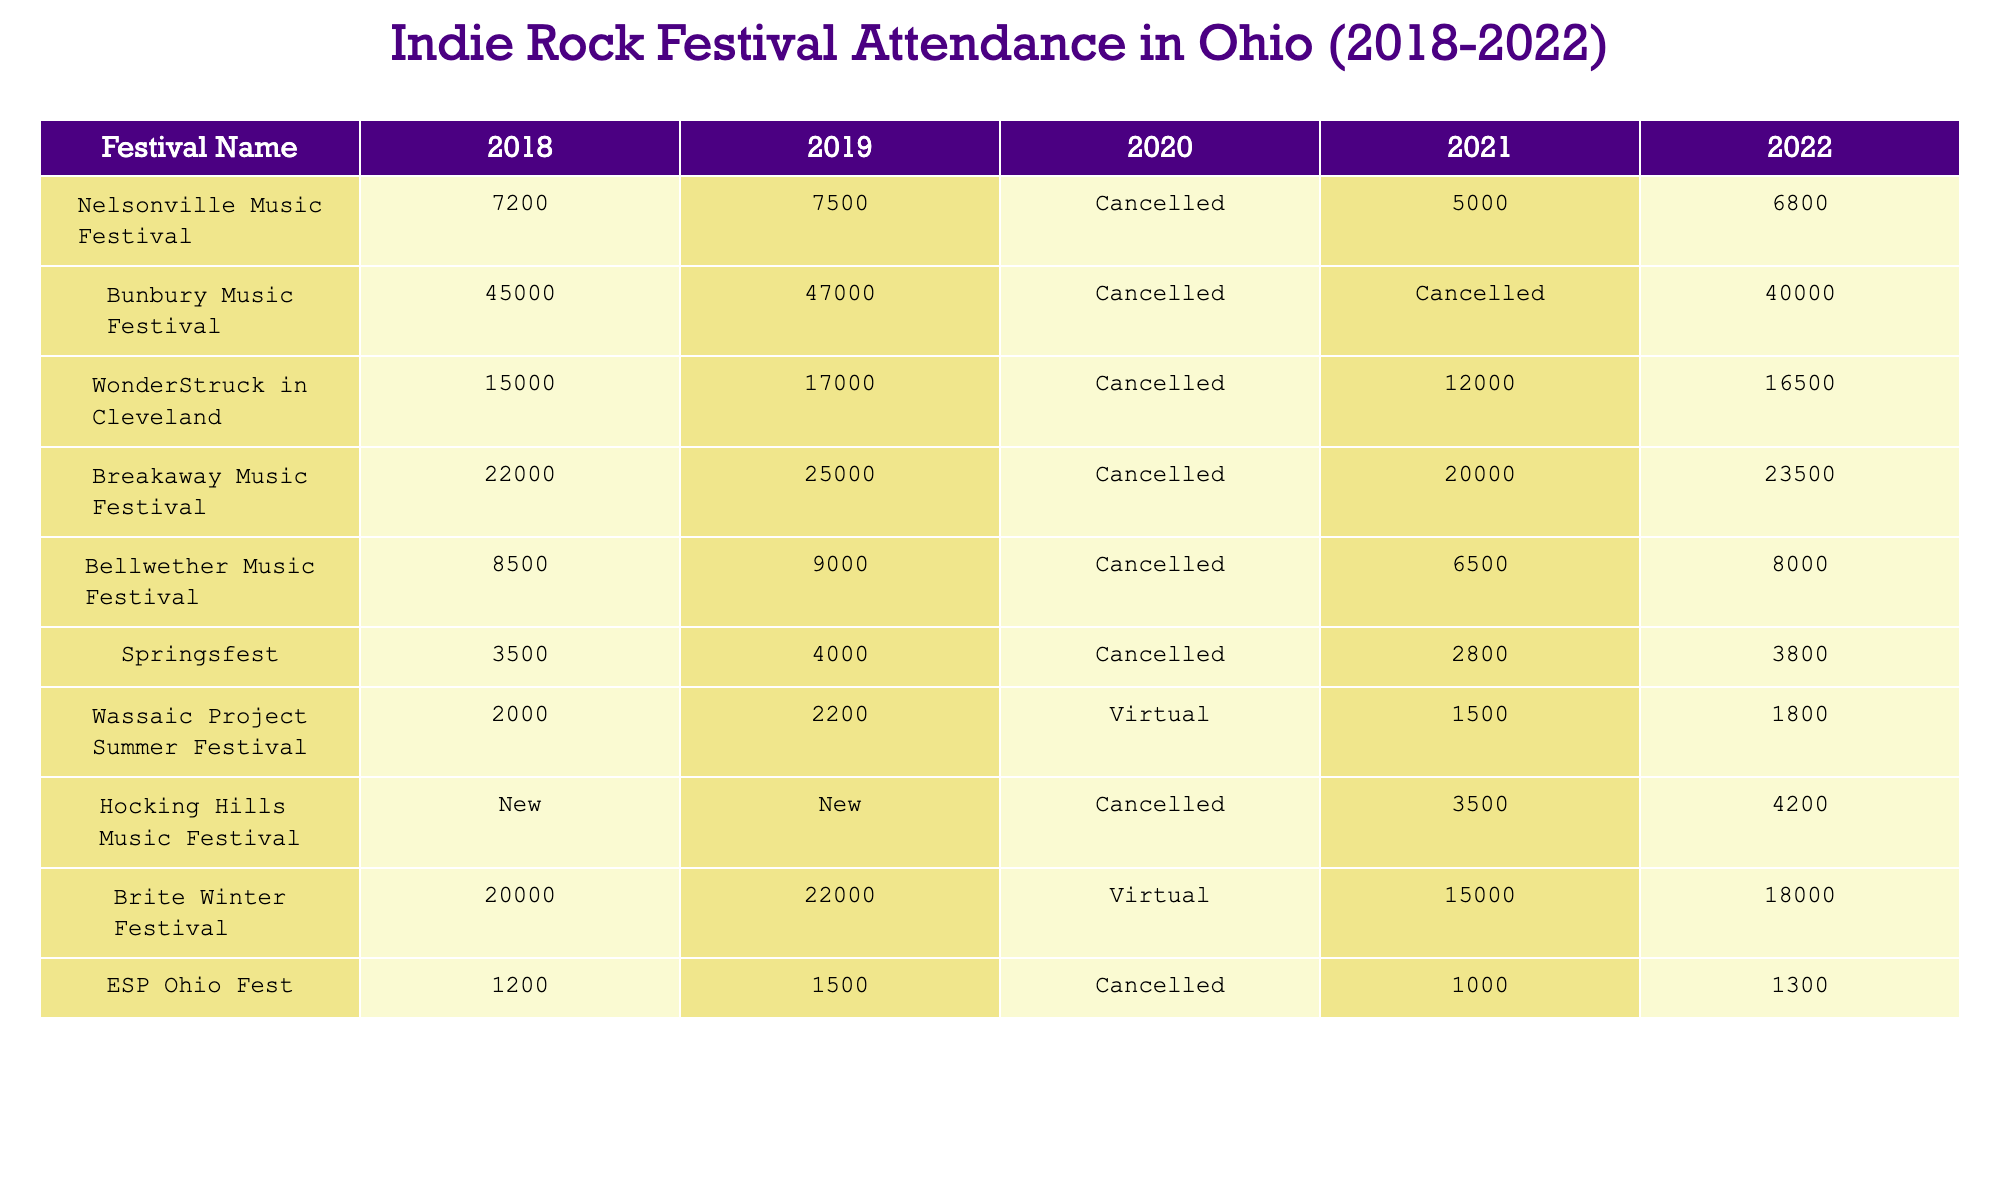What was the attendance at the Nelsonville Music Festival in 2021? The table shows that the Nelsonville Music Festival was cancelled in 2021, which is indicated clearly in the corresponding cell.
Answer: Cancelled Which festival had the highest attendance in 2019? Looking at the 2019 column, the Bunbury Music Festival had the highest attendance of 47,000, compared to the other festivals listed.
Answer: 47000 What is the average attendance for Breakaway Music Festival from 2018 to 2022, excluding the cancelled years? The attendance numbers for the Breakaway Music Festival are 22,000 (2018), 25,000 (2019), 20,000 (2021), and 23,500 (2022). To find the average, we sum these: 22,000 + 25,000 + 20,000 + 23,500 = 90,500 and divide by 4 (the number of years): 90,500 / 4 = 22,625.
Answer: 22625 Did the attendance for the Wassaic Project Summer Festival increase from 2020 to 2022? The Wassaic Project Summer Festival had a virtual event in 2020 (attendance not applicable), with attendance figures of 1,500 in 2021 and 1,800 in 2022. Since 1,800 is greater than 1,500, the attendance increased from 2021 to 2022.
Answer: Yes What is the difference in total attendance between the Brite Winter Festival in 2018 and 2022? For the Brite Winter Festival, the attendance in 2018 was 20,000 and in 2022 it was 18,000. The difference can be calculated as 20,000 - 18,000 = 2,000.
Answer: 2000 